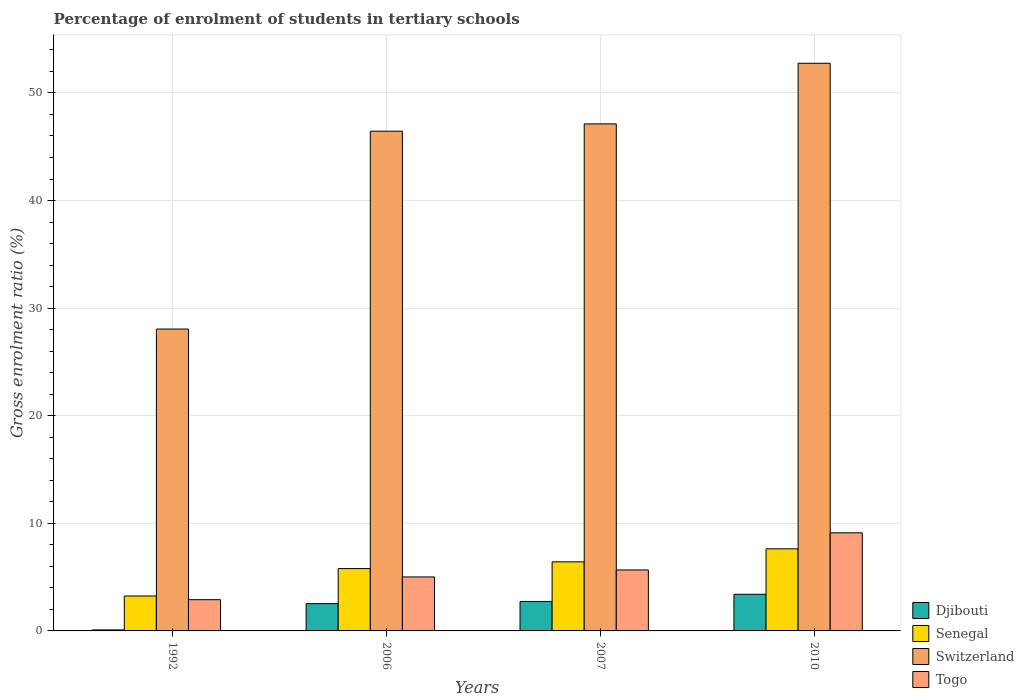How many different coloured bars are there?
Provide a short and direct response. 4. How many groups of bars are there?
Keep it short and to the point. 4. Are the number of bars on each tick of the X-axis equal?
Your response must be concise. Yes. How many bars are there on the 4th tick from the right?
Your answer should be very brief. 4. What is the label of the 4th group of bars from the left?
Ensure brevity in your answer.  2010. What is the percentage of students enrolled in tertiary schools in Djibouti in 1992?
Keep it short and to the point. 0.09. Across all years, what is the maximum percentage of students enrolled in tertiary schools in Senegal?
Your response must be concise. 7.63. Across all years, what is the minimum percentage of students enrolled in tertiary schools in Togo?
Make the answer very short. 2.9. In which year was the percentage of students enrolled in tertiary schools in Senegal maximum?
Your answer should be compact. 2010. What is the total percentage of students enrolled in tertiary schools in Senegal in the graph?
Make the answer very short. 23.09. What is the difference between the percentage of students enrolled in tertiary schools in Djibouti in 1992 and that in 2010?
Your answer should be very brief. -3.31. What is the difference between the percentage of students enrolled in tertiary schools in Djibouti in 2010 and the percentage of students enrolled in tertiary schools in Senegal in 2006?
Provide a short and direct response. -2.39. What is the average percentage of students enrolled in tertiary schools in Togo per year?
Offer a very short reply. 5.68. In the year 2007, what is the difference between the percentage of students enrolled in tertiary schools in Djibouti and percentage of students enrolled in tertiary schools in Switzerland?
Make the answer very short. -44.38. What is the ratio of the percentage of students enrolled in tertiary schools in Switzerland in 2007 to that in 2010?
Offer a terse response. 0.89. Is the difference between the percentage of students enrolled in tertiary schools in Djibouti in 1992 and 2006 greater than the difference between the percentage of students enrolled in tertiary schools in Switzerland in 1992 and 2006?
Your response must be concise. Yes. What is the difference between the highest and the second highest percentage of students enrolled in tertiary schools in Switzerland?
Ensure brevity in your answer.  5.63. What is the difference between the highest and the lowest percentage of students enrolled in tertiary schools in Switzerland?
Keep it short and to the point. 24.7. Is the sum of the percentage of students enrolled in tertiary schools in Senegal in 2006 and 2010 greater than the maximum percentage of students enrolled in tertiary schools in Switzerland across all years?
Ensure brevity in your answer.  No. Is it the case that in every year, the sum of the percentage of students enrolled in tertiary schools in Djibouti and percentage of students enrolled in tertiary schools in Togo is greater than the sum of percentage of students enrolled in tertiary schools in Senegal and percentage of students enrolled in tertiary schools in Switzerland?
Ensure brevity in your answer.  No. What does the 2nd bar from the left in 2006 represents?
Offer a terse response. Senegal. What does the 3rd bar from the right in 2010 represents?
Provide a short and direct response. Senegal. How many bars are there?
Give a very brief answer. 16. Are all the bars in the graph horizontal?
Provide a short and direct response. No. How many years are there in the graph?
Your response must be concise. 4. What is the title of the graph?
Your response must be concise. Percentage of enrolment of students in tertiary schools. What is the Gross enrolment ratio (%) in Djibouti in 1992?
Keep it short and to the point. 0.09. What is the Gross enrolment ratio (%) in Senegal in 1992?
Keep it short and to the point. 3.25. What is the Gross enrolment ratio (%) in Switzerland in 1992?
Give a very brief answer. 28.06. What is the Gross enrolment ratio (%) in Togo in 1992?
Make the answer very short. 2.9. What is the Gross enrolment ratio (%) of Djibouti in 2006?
Offer a very short reply. 2.54. What is the Gross enrolment ratio (%) of Senegal in 2006?
Ensure brevity in your answer.  5.79. What is the Gross enrolment ratio (%) in Switzerland in 2006?
Offer a terse response. 46.44. What is the Gross enrolment ratio (%) of Togo in 2006?
Offer a very short reply. 5.02. What is the Gross enrolment ratio (%) of Djibouti in 2007?
Your answer should be compact. 2.74. What is the Gross enrolment ratio (%) of Senegal in 2007?
Provide a succinct answer. 6.42. What is the Gross enrolment ratio (%) in Switzerland in 2007?
Give a very brief answer. 47.12. What is the Gross enrolment ratio (%) in Togo in 2007?
Offer a terse response. 5.67. What is the Gross enrolment ratio (%) in Djibouti in 2010?
Make the answer very short. 3.41. What is the Gross enrolment ratio (%) of Senegal in 2010?
Offer a very short reply. 7.63. What is the Gross enrolment ratio (%) of Switzerland in 2010?
Ensure brevity in your answer.  52.76. What is the Gross enrolment ratio (%) in Togo in 2010?
Your answer should be compact. 9.12. Across all years, what is the maximum Gross enrolment ratio (%) in Djibouti?
Give a very brief answer. 3.41. Across all years, what is the maximum Gross enrolment ratio (%) in Senegal?
Provide a short and direct response. 7.63. Across all years, what is the maximum Gross enrolment ratio (%) in Switzerland?
Offer a terse response. 52.76. Across all years, what is the maximum Gross enrolment ratio (%) in Togo?
Your answer should be very brief. 9.12. Across all years, what is the minimum Gross enrolment ratio (%) in Djibouti?
Your answer should be very brief. 0.09. Across all years, what is the minimum Gross enrolment ratio (%) in Senegal?
Keep it short and to the point. 3.25. Across all years, what is the minimum Gross enrolment ratio (%) in Switzerland?
Ensure brevity in your answer.  28.06. Across all years, what is the minimum Gross enrolment ratio (%) in Togo?
Your answer should be compact. 2.9. What is the total Gross enrolment ratio (%) of Djibouti in the graph?
Provide a short and direct response. 8.78. What is the total Gross enrolment ratio (%) of Senegal in the graph?
Your response must be concise. 23.09. What is the total Gross enrolment ratio (%) in Switzerland in the graph?
Your answer should be very brief. 174.38. What is the total Gross enrolment ratio (%) of Togo in the graph?
Make the answer very short. 22.7. What is the difference between the Gross enrolment ratio (%) of Djibouti in 1992 and that in 2006?
Your answer should be compact. -2.44. What is the difference between the Gross enrolment ratio (%) of Senegal in 1992 and that in 2006?
Your answer should be compact. -2.54. What is the difference between the Gross enrolment ratio (%) in Switzerland in 1992 and that in 2006?
Offer a terse response. -18.39. What is the difference between the Gross enrolment ratio (%) in Togo in 1992 and that in 2006?
Offer a very short reply. -2.11. What is the difference between the Gross enrolment ratio (%) of Djibouti in 1992 and that in 2007?
Offer a very short reply. -2.64. What is the difference between the Gross enrolment ratio (%) of Senegal in 1992 and that in 2007?
Keep it short and to the point. -3.17. What is the difference between the Gross enrolment ratio (%) of Switzerland in 1992 and that in 2007?
Offer a very short reply. -19.07. What is the difference between the Gross enrolment ratio (%) in Togo in 1992 and that in 2007?
Keep it short and to the point. -2.76. What is the difference between the Gross enrolment ratio (%) of Djibouti in 1992 and that in 2010?
Provide a short and direct response. -3.31. What is the difference between the Gross enrolment ratio (%) of Senegal in 1992 and that in 2010?
Your response must be concise. -4.38. What is the difference between the Gross enrolment ratio (%) of Switzerland in 1992 and that in 2010?
Your answer should be very brief. -24.7. What is the difference between the Gross enrolment ratio (%) of Togo in 1992 and that in 2010?
Your answer should be compact. -6.21. What is the difference between the Gross enrolment ratio (%) in Djibouti in 2006 and that in 2007?
Your answer should be very brief. -0.2. What is the difference between the Gross enrolment ratio (%) of Senegal in 2006 and that in 2007?
Keep it short and to the point. -0.63. What is the difference between the Gross enrolment ratio (%) of Switzerland in 2006 and that in 2007?
Provide a succinct answer. -0.68. What is the difference between the Gross enrolment ratio (%) in Togo in 2006 and that in 2007?
Your answer should be very brief. -0.65. What is the difference between the Gross enrolment ratio (%) of Djibouti in 2006 and that in 2010?
Provide a succinct answer. -0.87. What is the difference between the Gross enrolment ratio (%) in Senegal in 2006 and that in 2010?
Offer a terse response. -1.84. What is the difference between the Gross enrolment ratio (%) in Switzerland in 2006 and that in 2010?
Give a very brief answer. -6.31. What is the difference between the Gross enrolment ratio (%) of Togo in 2006 and that in 2010?
Your answer should be very brief. -4.1. What is the difference between the Gross enrolment ratio (%) of Djibouti in 2007 and that in 2010?
Keep it short and to the point. -0.67. What is the difference between the Gross enrolment ratio (%) of Senegal in 2007 and that in 2010?
Provide a short and direct response. -1.21. What is the difference between the Gross enrolment ratio (%) of Switzerland in 2007 and that in 2010?
Make the answer very short. -5.63. What is the difference between the Gross enrolment ratio (%) in Togo in 2007 and that in 2010?
Your answer should be compact. -3.45. What is the difference between the Gross enrolment ratio (%) in Djibouti in 1992 and the Gross enrolment ratio (%) in Senegal in 2006?
Provide a succinct answer. -5.7. What is the difference between the Gross enrolment ratio (%) of Djibouti in 1992 and the Gross enrolment ratio (%) of Switzerland in 2006?
Offer a very short reply. -46.35. What is the difference between the Gross enrolment ratio (%) in Djibouti in 1992 and the Gross enrolment ratio (%) in Togo in 2006?
Your answer should be very brief. -4.92. What is the difference between the Gross enrolment ratio (%) of Senegal in 1992 and the Gross enrolment ratio (%) of Switzerland in 2006?
Your answer should be very brief. -43.2. What is the difference between the Gross enrolment ratio (%) of Senegal in 1992 and the Gross enrolment ratio (%) of Togo in 2006?
Provide a short and direct response. -1.77. What is the difference between the Gross enrolment ratio (%) of Switzerland in 1992 and the Gross enrolment ratio (%) of Togo in 2006?
Your response must be concise. 23.04. What is the difference between the Gross enrolment ratio (%) in Djibouti in 1992 and the Gross enrolment ratio (%) in Senegal in 2007?
Your response must be concise. -6.32. What is the difference between the Gross enrolment ratio (%) in Djibouti in 1992 and the Gross enrolment ratio (%) in Switzerland in 2007?
Provide a short and direct response. -47.03. What is the difference between the Gross enrolment ratio (%) of Djibouti in 1992 and the Gross enrolment ratio (%) of Togo in 2007?
Give a very brief answer. -5.57. What is the difference between the Gross enrolment ratio (%) of Senegal in 1992 and the Gross enrolment ratio (%) of Switzerland in 2007?
Offer a terse response. -43.88. What is the difference between the Gross enrolment ratio (%) in Senegal in 1992 and the Gross enrolment ratio (%) in Togo in 2007?
Provide a succinct answer. -2.42. What is the difference between the Gross enrolment ratio (%) of Switzerland in 1992 and the Gross enrolment ratio (%) of Togo in 2007?
Keep it short and to the point. 22.39. What is the difference between the Gross enrolment ratio (%) in Djibouti in 1992 and the Gross enrolment ratio (%) in Senegal in 2010?
Offer a very short reply. -7.54. What is the difference between the Gross enrolment ratio (%) of Djibouti in 1992 and the Gross enrolment ratio (%) of Switzerland in 2010?
Your answer should be compact. -52.66. What is the difference between the Gross enrolment ratio (%) of Djibouti in 1992 and the Gross enrolment ratio (%) of Togo in 2010?
Your answer should be compact. -9.02. What is the difference between the Gross enrolment ratio (%) of Senegal in 1992 and the Gross enrolment ratio (%) of Switzerland in 2010?
Keep it short and to the point. -49.51. What is the difference between the Gross enrolment ratio (%) in Senegal in 1992 and the Gross enrolment ratio (%) in Togo in 2010?
Offer a terse response. -5.87. What is the difference between the Gross enrolment ratio (%) of Switzerland in 1992 and the Gross enrolment ratio (%) of Togo in 2010?
Provide a succinct answer. 18.94. What is the difference between the Gross enrolment ratio (%) of Djibouti in 2006 and the Gross enrolment ratio (%) of Senegal in 2007?
Give a very brief answer. -3.88. What is the difference between the Gross enrolment ratio (%) in Djibouti in 2006 and the Gross enrolment ratio (%) in Switzerland in 2007?
Make the answer very short. -44.59. What is the difference between the Gross enrolment ratio (%) of Djibouti in 2006 and the Gross enrolment ratio (%) of Togo in 2007?
Your answer should be compact. -3.13. What is the difference between the Gross enrolment ratio (%) in Senegal in 2006 and the Gross enrolment ratio (%) in Switzerland in 2007?
Provide a succinct answer. -41.33. What is the difference between the Gross enrolment ratio (%) in Senegal in 2006 and the Gross enrolment ratio (%) in Togo in 2007?
Ensure brevity in your answer.  0.13. What is the difference between the Gross enrolment ratio (%) of Switzerland in 2006 and the Gross enrolment ratio (%) of Togo in 2007?
Give a very brief answer. 40.78. What is the difference between the Gross enrolment ratio (%) of Djibouti in 2006 and the Gross enrolment ratio (%) of Senegal in 2010?
Provide a short and direct response. -5.09. What is the difference between the Gross enrolment ratio (%) in Djibouti in 2006 and the Gross enrolment ratio (%) in Switzerland in 2010?
Provide a short and direct response. -50.22. What is the difference between the Gross enrolment ratio (%) in Djibouti in 2006 and the Gross enrolment ratio (%) in Togo in 2010?
Your response must be concise. -6.58. What is the difference between the Gross enrolment ratio (%) in Senegal in 2006 and the Gross enrolment ratio (%) in Switzerland in 2010?
Make the answer very short. -46.96. What is the difference between the Gross enrolment ratio (%) of Senegal in 2006 and the Gross enrolment ratio (%) of Togo in 2010?
Provide a succinct answer. -3.32. What is the difference between the Gross enrolment ratio (%) of Switzerland in 2006 and the Gross enrolment ratio (%) of Togo in 2010?
Make the answer very short. 37.33. What is the difference between the Gross enrolment ratio (%) of Djibouti in 2007 and the Gross enrolment ratio (%) of Senegal in 2010?
Make the answer very short. -4.89. What is the difference between the Gross enrolment ratio (%) of Djibouti in 2007 and the Gross enrolment ratio (%) of Switzerland in 2010?
Provide a succinct answer. -50.02. What is the difference between the Gross enrolment ratio (%) of Djibouti in 2007 and the Gross enrolment ratio (%) of Togo in 2010?
Your answer should be compact. -6.38. What is the difference between the Gross enrolment ratio (%) of Senegal in 2007 and the Gross enrolment ratio (%) of Switzerland in 2010?
Provide a short and direct response. -46.34. What is the difference between the Gross enrolment ratio (%) of Senegal in 2007 and the Gross enrolment ratio (%) of Togo in 2010?
Provide a succinct answer. -2.7. What is the difference between the Gross enrolment ratio (%) of Switzerland in 2007 and the Gross enrolment ratio (%) of Togo in 2010?
Offer a very short reply. 38.01. What is the average Gross enrolment ratio (%) in Djibouti per year?
Your response must be concise. 2.19. What is the average Gross enrolment ratio (%) in Senegal per year?
Make the answer very short. 5.77. What is the average Gross enrolment ratio (%) in Switzerland per year?
Make the answer very short. 43.6. What is the average Gross enrolment ratio (%) in Togo per year?
Keep it short and to the point. 5.68. In the year 1992, what is the difference between the Gross enrolment ratio (%) in Djibouti and Gross enrolment ratio (%) in Senegal?
Your response must be concise. -3.15. In the year 1992, what is the difference between the Gross enrolment ratio (%) in Djibouti and Gross enrolment ratio (%) in Switzerland?
Your answer should be compact. -27.96. In the year 1992, what is the difference between the Gross enrolment ratio (%) in Djibouti and Gross enrolment ratio (%) in Togo?
Your answer should be very brief. -2.81. In the year 1992, what is the difference between the Gross enrolment ratio (%) in Senegal and Gross enrolment ratio (%) in Switzerland?
Give a very brief answer. -24.81. In the year 1992, what is the difference between the Gross enrolment ratio (%) in Senegal and Gross enrolment ratio (%) in Togo?
Offer a terse response. 0.34. In the year 1992, what is the difference between the Gross enrolment ratio (%) in Switzerland and Gross enrolment ratio (%) in Togo?
Your answer should be compact. 25.15. In the year 2006, what is the difference between the Gross enrolment ratio (%) of Djibouti and Gross enrolment ratio (%) of Senegal?
Your answer should be very brief. -3.26. In the year 2006, what is the difference between the Gross enrolment ratio (%) of Djibouti and Gross enrolment ratio (%) of Switzerland?
Provide a succinct answer. -43.91. In the year 2006, what is the difference between the Gross enrolment ratio (%) in Djibouti and Gross enrolment ratio (%) in Togo?
Ensure brevity in your answer.  -2.48. In the year 2006, what is the difference between the Gross enrolment ratio (%) of Senegal and Gross enrolment ratio (%) of Switzerland?
Ensure brevity in your answer.  -40.65. In the year 2006, what is the difference between the Gross enrolment ratio (%) in Senegal and Gross enrolment ratio (%) in Togo?
Offer a terse response. 0.77. In the year 2006, what is the difference between the Gross enrolment ratio (%) in Switzerland and Gross enrolment ratio (%) in Togo?
Your answer should be very brief. 41.43. In the year 2007, what is the difference between the Gross enrolment ratio (%) of Djibouti and Gross enrolment ratio (%) of Senegal?
Your answer should be very brief. -3.68. In the year 2007, what is the difference between the Gross enrolment ratio (%) in Djibouti and Gross enrolment ratio (%) in Switzerland?
Ensure brevity in your answer.  -44.38. In the year 2007, what is the difference between the Gross enrolment ratio (%) of Djibouti and Gross enrolment ratio (%) of Togo?
Your answer should be compact. -2.93. In the year 2007, what is the difference between the Gross enrolment ratio (%) of Senegal and Gross enrolment ratio (%) of Switzerland?
Offer a terse response. -40.7. In the year 2007, what is the difference between the Gross enrolment ratio (%) of Senegal and Gross enrolment ratio (%) of Togo?
Make the answer very short. 0.75. In the year 2007, what is the difference between the Gross enrolment ratio (%) of Switzerland and Gross enrolment ratio (%) of Togo?
Ensure brevity in your answer.  41.46. In the year 2010, what is the difference between the Gross enrolment ratio (%) in Djibouti and Gross enrolment ratio (%) in Senegal?
Keep it short and to the point. -4.22. In the year 2010, what is the difference between the Gross enrolment ratio (%) of Djibouti and Gross enrolment ratio (%) of Switzerland?
Your answer should be very brief. -49.35. In the year 2010, what is the difference between the Gross enrolment ratio (%) of Djibouti and Gross enrolment ratio (%) of Togo?
Provide a short and direct response. -5.71. In the year 2010, what is the difference between the Gross enrolment ratio (%) in Senegal and Gross enrolment ratio (%) in Switzerland?
Your response must be concise. -45.13. In the year 2010, what is the difference between the Gross enrolment ratio (%) of Senegal and Gross enrolment ratio (%) of Togo?
Offer a terse response. -1.49. In the year 2010, what is the difference between the Gross enrolment ratio (%) of Switzerland and Gross enrolment ratio (%) of Togo?
Provide a succinct answer. 43.64. What is the ratio of the Gross enrolment ratio (%) of Djibouti in 1992 to that in 2006?
Offer a terse response. 0.04. What is the ratio of the Gross enrolment ratio (%) in Senegal in 1992 to that in 2006?
Provide a succinct answer. 0.56. What is the ratio of the Gross enrolment ratio (%) in Switzerland in 1992 to that in 2006?
Keep it short and to the point. 0.6. What is the ratio of the Gross enrolment ratio (%) in Togo in 1992 to that in 2006?
Offer a very short reply. 0.58. What is the ratio of the Gross enrolment ratio (%) of Djibouti in 1992 to that in 2007?
Offer a very short reply. 0.03. What is the ratio of the Gross enrolment ratio (%) of Senegal in 1992 to that in 2007?
Ensure brevity in your answer.  0.51. What is the ratio of the Gross enrolment ratio (%) of Switzerland in 1992 to that in 2007?
Provide a short and direct response. 0.6. What is the ratio of the Gross enrolment ratio (%) of Togo in 1992 to that in 2007?
Your answer should be very brief. 0.51. What is the ratio of the Gross enrolment ratio (%) in Djibouti in 1992 to that in 2010?
Offer a very short reply. 0.03. What is the ratio of the Gross enrolment ratio (%) in Senegal in 1992 to that in 2010?
Make the answer very short. 0.43. What is the ratio of the Gross enrolment ratio (%) in Switzerland in 1992 to that in 2010?
Your answer should be very brief. 0.53. What is the ratio of the Gross enrolment ratio (%) of Togo in 1992 to that in 2010?
Provide a short and direct response. 0.32. What is the ratio of the Gross enrolment ratio (%) of Djibouti in 2006 to that in 2007?
Provide a short and direct response. 0.93. What is the ratio of the Gross enrolment ratio (%) of Senegal in 2006 to that in 2007?
Your response must be concise. 0.9. What is the ratio of the Gross enrolment ratio (%) of Switzerland in 2006 to that in 2007?
Offer a very short reply. 0.99. What is the ratio of the Gross enrolment ratio (%) of Togo in 2006 to that in 2007?
Your answer should be compact. 0.89. What is the ratio of the Gross enrolment ratio (%) of Djibouti in 2006 to that in 2010?
Ensure brevity in your answer.  0.74. What is the ratio of the Gross enrolment ratio (%) in Senegal in 2006 to that in 2010?
Make the answer very short. 0.76. What is the ratio of the Gross enrolment ratio (%) in Switzerland in 2006 to that in 2010?
Your answer should be compact. 0.88. What is the ratio of the Gross enrolment ratio (%) in Togo in 2006 to that in 2010?
Keep it short and to the point. 0.55. What is the ratio of the Gross enrolment ratio (%) of Djibouti in 2007 to that in 2010?
Your answer should be compact. 0.8. What is the ratio of the Gross enrolment ratio (%) in Senegal in 2007 to that in 2010?
Make the answer very short. 0.84. What is the ratio of the Gross enrolment ratio (%) in Switzerland in 2007 to that in 2010?
Offer a terse response. 0.89. What is the ratio of the Gross enrolment ratio (%) in Togo in 2007 to that in 2010?
Make the answer very short. 0.62. What is the difference between the highest and the second highest Gross enrolment ratio (%) in Djibouti?
Your response must be concise. 0.67. What is the difference between the highest and the second highest Gross enrolment ratio (%) in Senegal?
Your response must be concise. 1.21. What is the difference between the highest and the second highest Gross enrolment ratio (%) of Switzerland?
Provide a short and direct response. 5.63. What is the difference between the highest and the second highest Gross enrolment ratio (%) of Togo?
Give a very brief answer. 3.45. What is the difference between the highest and the lowest Gross enrolment ratio (%) in Djibouti?
Your answer should be very brief. 3.31. What is the difference between the highest and the lowest Gross enrolment ratio (%) in Senegal?
Provide a succinct answer. 4.38. What is the difference between the highest and the lowest Gross enrolment ratio (%) of Switzerland?
Offer a very short reply. 24.7. What is the difference between the highest and the lowest Gross enrolment ratio (%) of Togo?
Provide a short and direct response. 6.21. 